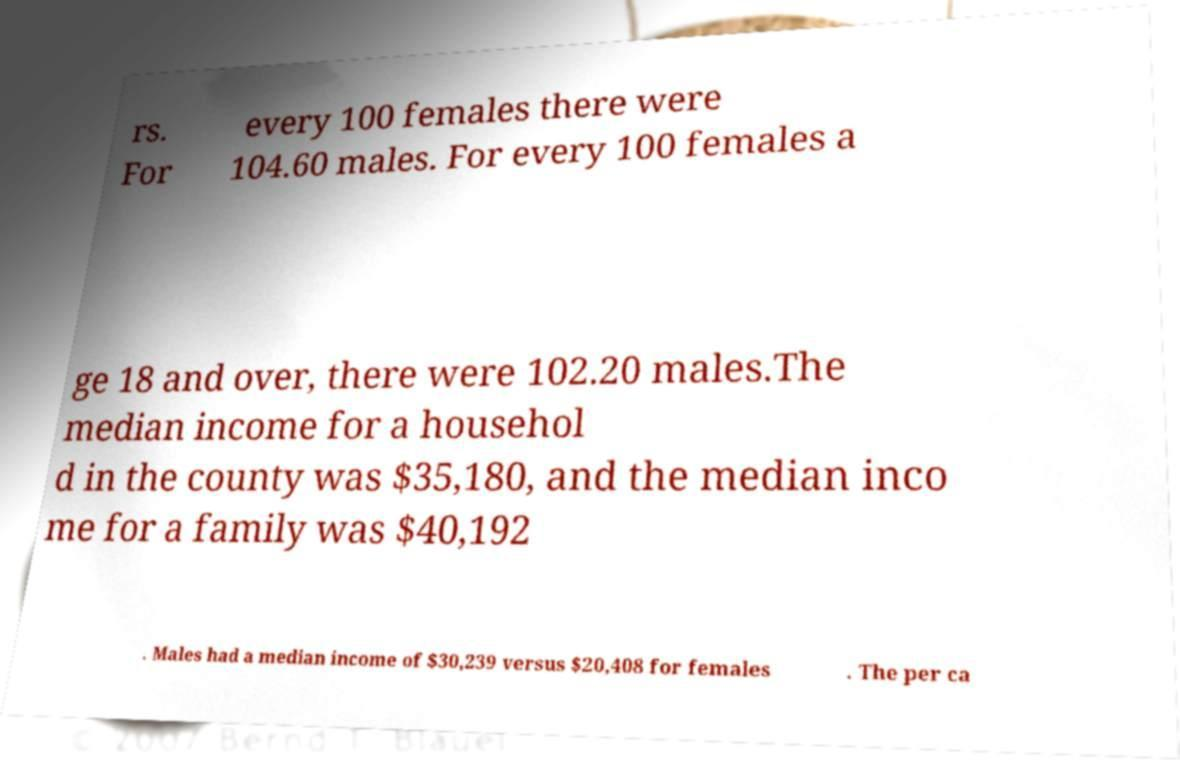What messages or text are displayed in this image? I need them in a readable, typed format. rs. For every 100 females there were 104.60 males. For every 100 females a ge 18 and over, there were 102.20 males.The median income for a househol d in the county was $35,180, and the median inco me for a family was $40,192 . Males had a median income of $30,239 versus $20,408 for females . The per ca 